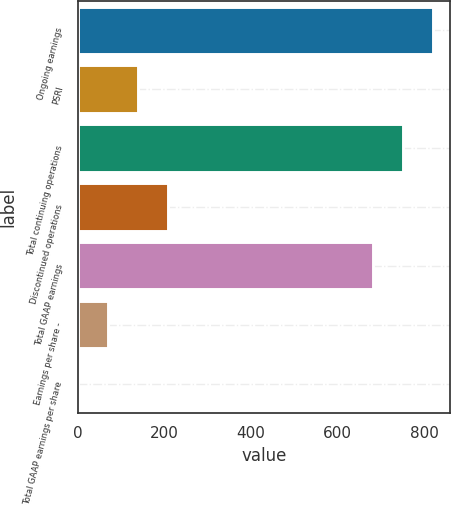Convert chart to OTSL. <chart><loc_0><loc_0><loc_500><loc_500><bar_chart><fcel>Ongoing earnings<fcel>PSRI<fcel>Total continuing operations<fcel>Discontinued operations<fcel>Total GAAP earnings<fcel>Earnings per share -<fcel>Total GAAP earnings per share<nl><fcel>818.6<fcel>139.18<fcel>749.75<fcel>208.03<fcel>680.9<fcel>70.33<fcel>1.48<nl></chart> 